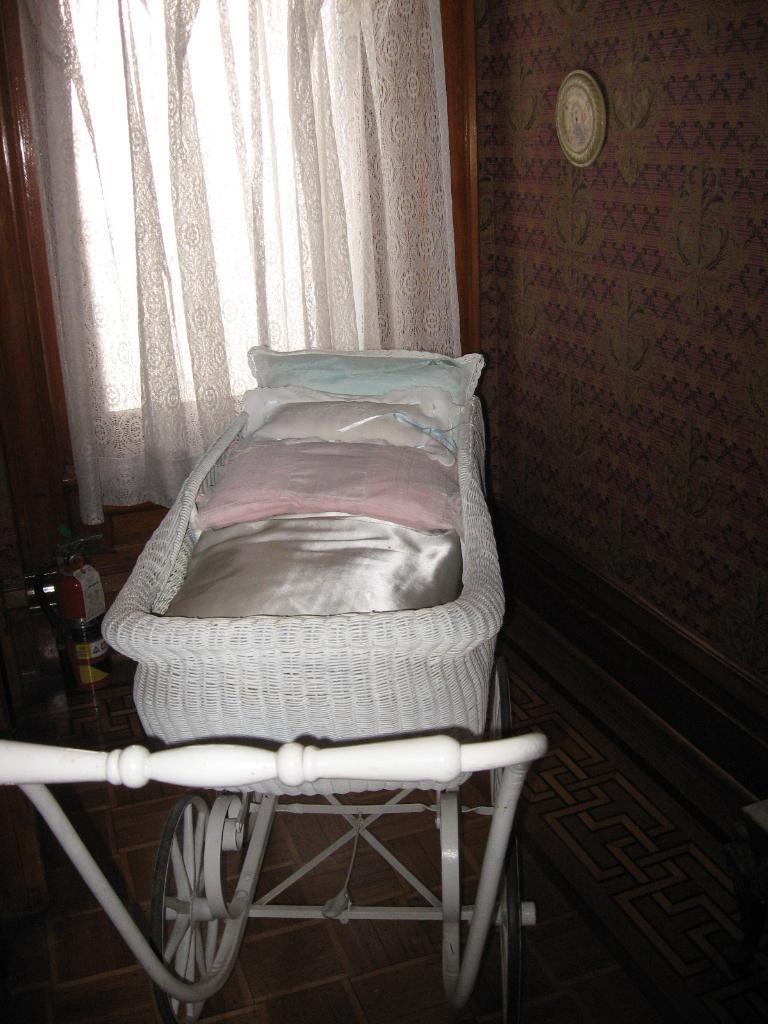Describe this image in one or two sentences. In this image I can see a trolley in the front and in it I can see few cushions. In the background I can see a white colour curtain and on the right side of this image I can see a round thing on the wall. I can also see a fire extinguisher on the left side. 